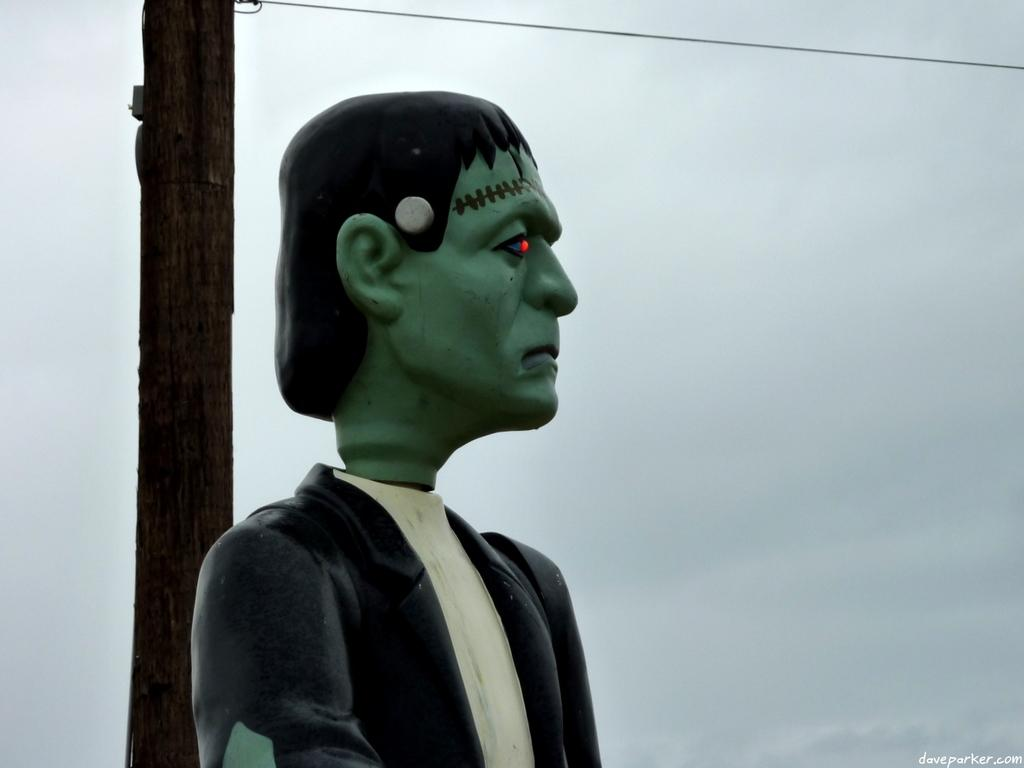What is the main subject in the image? There is a sculpture of a man in the image. What can be seen in the background of the image? The sky is visible in the background of the image. What is the condition of the sky in the image? There are clouds in the sky in the background of the image. Where is the place where the man's mom is walking in the image? There is no place or person walking in the image; it only features a sculpture of a man and the sky in the background. 